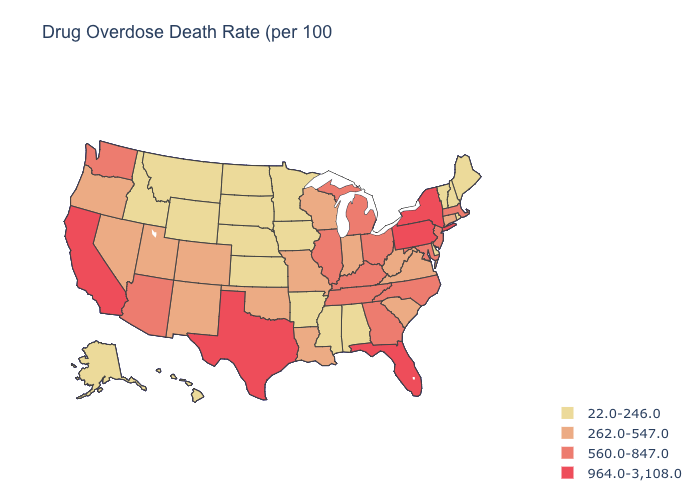Which states have the lowest value in the South?
Keep it brief. Alabama, Arkansas, Delaware, Mississippi. What is the value of Texas?
Be succinct. 964.0-3,108.0. Does the map have missing data?
Give a very brief answer. No. Does Alabama have the lowest value in the South?
Be succinct. Yes. What is the value of Wyoming?
Short answer required. 22.0-246.0. What is the value of Vermont?
Answer briefly. 22.0-246.0. Does Colorado have the lowest value in the USA?
Write a very short answer. No. What is the value of Nevada?
Quick response, please. 262.0-547.0. Name the states that have a value in the range 22.0-246.0?
Give a very brief answer. Alabama, Alaska, Arkansas, Delaware, Hawaii, Idaho, Iowa, Kansas, Maine, Minnesota, Mississippi, Montana, Nebraska, New Hampshire, North Dakota, Rhode Island, South Dakota, Vermont, Wyoming. What is the value of Alaska?
Concise answer only. 22.0-246.0. Does Florida have the highest value in the South?
Answer briefly. Yes. What is the lowest value in the West?
Keep it brief. 22.0-246.0. Is the legend a continuous bar?
Write a very short answer. No. What is the lowest value in states that border New York?
Quick response, please. 22.0-246.0. What is the highest value in states that border Louisiana?
Be succinct. 964.0-3,108.0. 